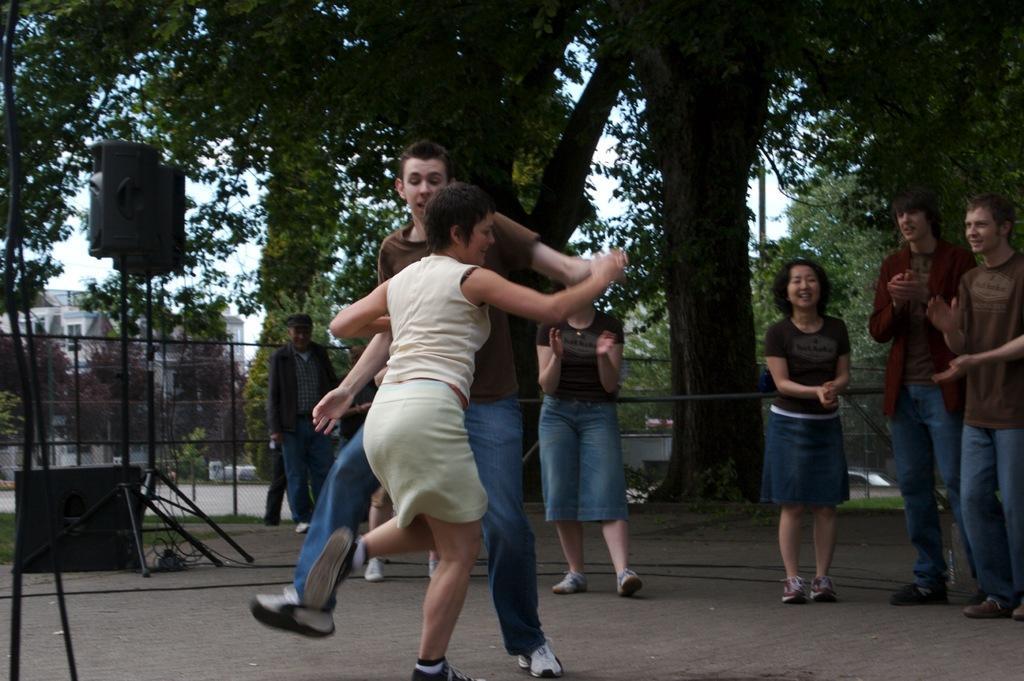Could you give a brief overview of what you see in this image? In this picture I can see two people are dancing on the ground and also I can see few people standing, behind we can see some speakers, trees, buildings and fencing. 